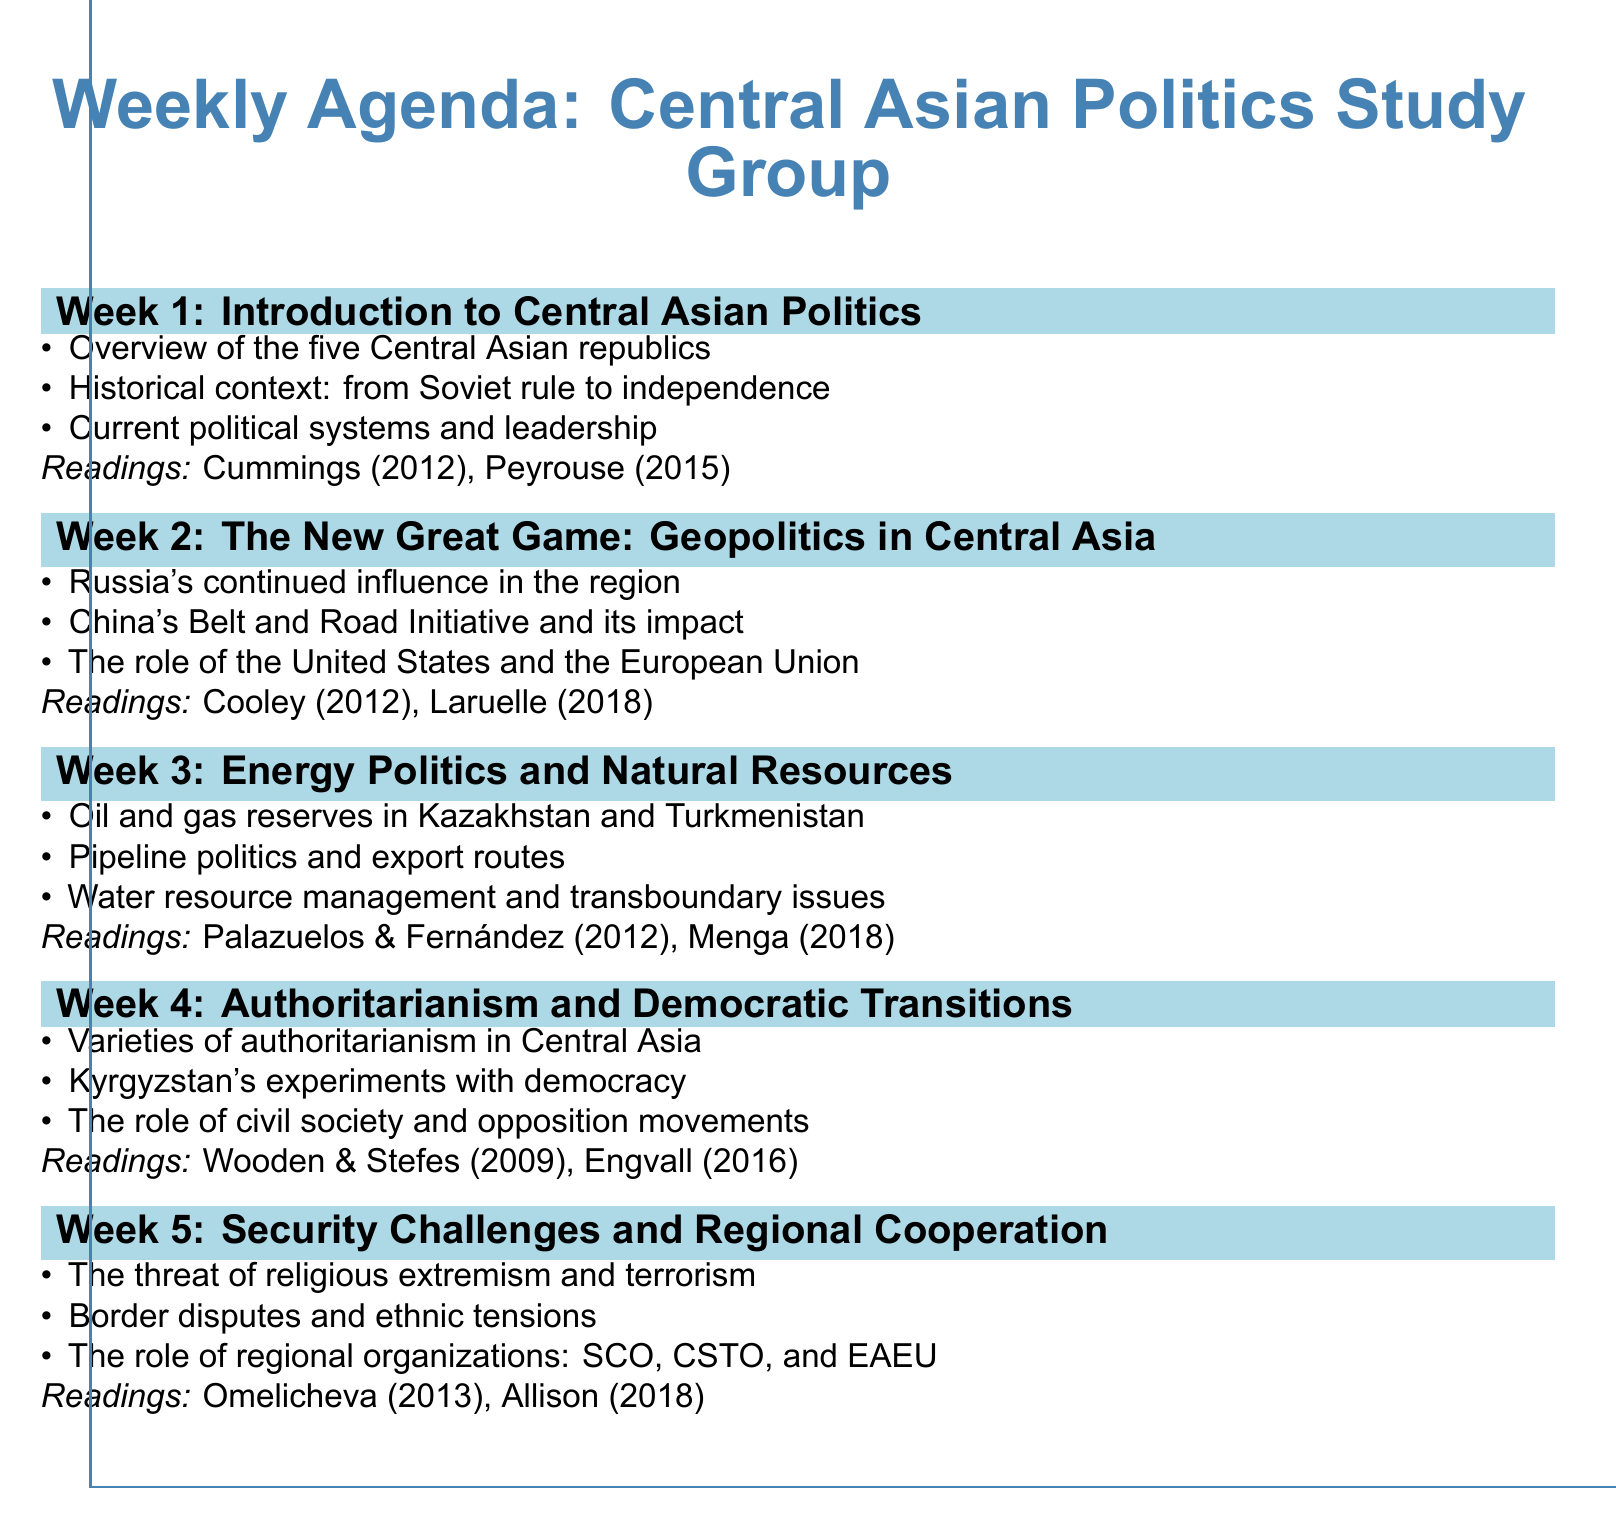What is the topic of Week 1? The topic is specified in the agenda for Week 1 and is "Introduction to Central Asian Politics."
Answer: Introduction to Central Asian Politics How many Central Asian republics are discussed? The document mentions five Central Asian republics in Week 1's discussion points.
Answer: Five What is the title of the assigned reading for Week 2 authored by Cooley? The title is listed under assigned readings for Week 2 and is "Great Games, Local Rules: The New Great Power Contest in Central Asia."
Answer: Great Games, Local Rules: The New Great Power Contest in Central Asia What issue is highlighted in Week 5's discussion points? The discussion points for Week 5 mention several issues, and one is "The threat of religious extremism and terrorism."
Answer: The threat of religious extremism and terrorism Which author wrote about Kyrgyzstan's democratic experiments? The author is specified in Week 4's assigned readings and is Engvall.
Answer: Engvall How many discussion points are listed for Week 4? The document outlines three discussion points for Week 4 in relation to authoritarianism and democratic transitions.
Answer: Three What organization is mentioned in Week 5 as relevant to security cooperation? The agenda for Week 5 includes the Shanghai Cooperation Organization (SCO) in the discussion points.
Answer: SCO Which chapter of Menga's book is suggested for Week 3? The assigned readings for Week 3 indicate "Chapters 2-3" of Menga's book.
Answer: Chapters 2-3 What reading is assigned for the topic on energy politics? The assigned readings for Week 3 include specific articles, one of which is by Palazuelos and Fernández.
Answer: Palazuelos & Fernández (2012) 